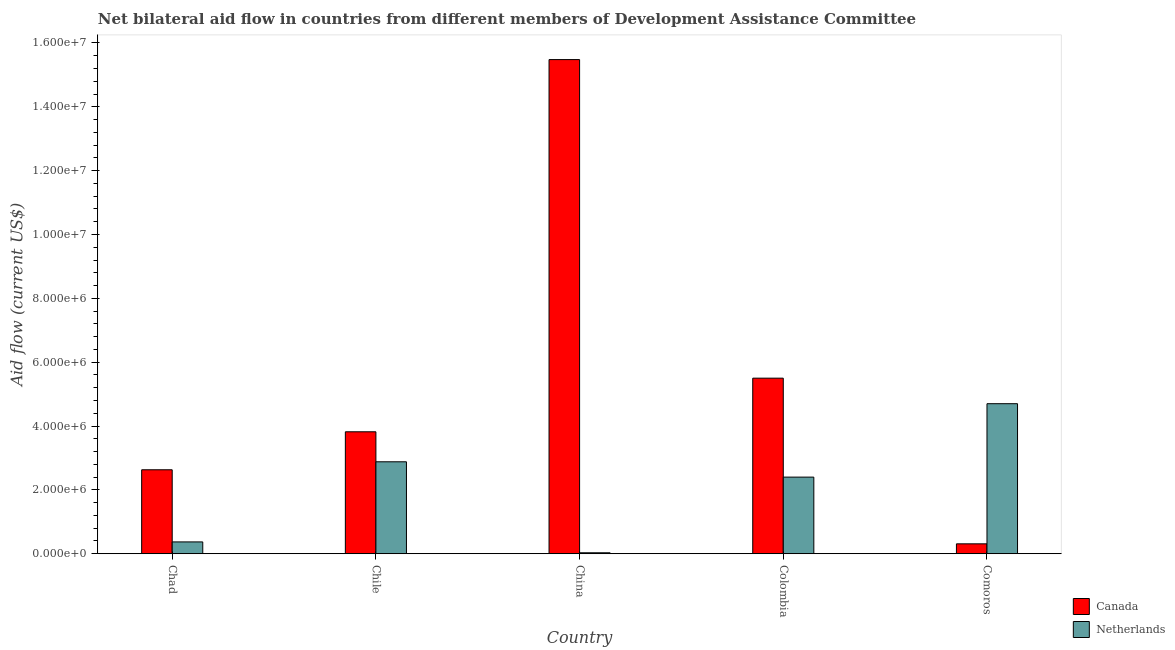How many different coloured bars are there?
Keep it short and to the point. 2. How many groups of bars are there?
Your response must be concise. 5. Are the number of bars on each tick of the X-axis equal?
Your answer should be very brief. Yes. What is the label of the 4th group of bars from the left?
Offer a very short reply. Colombia. What is the amount of aid given by netherlands in Colombia?
Your response must be concise. 2.40e+06. Across all countries, what is the maximum amount of aid given by netherlands?
Keep it short and to the point. 4.70e+06. Across all countries, what is the minimum amount of aid given by netherlands?
Give a very brief answer. 3.00e+04. In which country was the amount of aid given by netherlands maximum?
Give a very brief answer. Comoros. In which country was the amount of aid given by canada minimum?
Keep it short and to the point. Comoros. What is the total amount of aid given by canada in the graph?
Your answer should be compact. 2.77e+07. What is the difference between the amount of aid given by canada in Chile and that in China?
Give a very brief answer. -1.17e+07. What is the difference between the amount of aid given by canada in Comoros and the amount of aid given by netherlands in Colombia?
Your answer should be very brief. -2.09e+06. What is the average amount of aid given by netherlands per country?
Keep it short and to the point. 2.08e+06. What is the difference between the amount of aid given by canada and amount of aid given by netherlands in Chile?
Keep it short and to the point. 9.40e+05. In how many countries, is the amount of aid given by canada greater than 7200000 US$?
Your answer should be compact. 1. What is the ratio of the amount of aid given by netherlands in China to that in Comoros?
Your answer should be compact. 0.01. Is the amount of aid given by netherlands in China less than that in Comoros?
Offer a terse response. Yes. Is the difference between the amount of aid given by canada in Chad and Chile greater than the difference between the amount of aid given by netherlands in Chad and Chile?
Give a very brief answer. Yes. What is the difference between the highest and the second highest amount of aid given by canada?
Give a very brief answer. 9.98e+06. What is the difference between the highest and the lowest amount of aid given by canada?
Ensure brevity in your answer.  1.52e+07. Is the sum of the amount of aid given by canada in Colombia and Comoros greater than the maximum amount of aid given by netherlands across all countries?
Provide a succinct answer. Yes. What does the 2nd bar from the left in Chad represents?
Your answer should be compact. Netherlands. What does the 2nd bar from the right in Colombia represents?
Ensure brevity in your answer.  Canada. How many bars are there?
Your answer should be very brief. 10. How many countries are there in the graph?
Make the answer very short. 5. Where does the legend appear in the graph?
Keep it short and to the point. Bottom right. What is the title of the graph?
Your answer should be very brief. Net bilateral aid flow in countries from different members of Development Assistance Committee. What is the Aid flow (current US$) of Canada in Chad?
Your answer should be very brief. 2.63e+06. What is the Aid flow (current US$) in Canada in Chile?
Your response must be concise. 3.82e+06. What is the Aid flow (current US$) of Netherlands in Chile?
Ensure brevity in your answer.  2.88e+06. What is the Aid flow (current US$) of Canada in China?
Keep it short and to the point. 1.55e+07. What is the Aid flow (current US$) of Canada in Colombia?
Offer a terse response. 5.50e+06. What is the Aid flow (current US$) in Netherlands in Colombia?
Your answer should be very brief. 2.40e+06. What is the Aid flow (current US$) of Netherlands in Comoros?
Provide a succinct answer. 4.70e+06. Across all countries, what is the maximum Aid flow (current US$) in Canada?
Give a very brief answer. 1.55e+07. Across all countries, what is the maximum Aid flow (current US$) of Netherlands?
Provide a short and direct response. 4.70e+06. Across all countries, what is the minimum Aid flow (current US$) of Canada?
Keep it short and to the point. 3.10e+05. Across all countries, what is the minimum Aid flow (current US$) of Netherlands?
Provide a short and direct response. 3.00e+04. What is the total Aid flow (current US$) of Canada in the graph?
Offer a terse response. 2.77e+07. What is the total Aid flow (current US$) of Netherlands in the graph?
Provide a short and direct response. 1.04e+07. What is the difference between the Aid flow (current US$) in Canada in Chad and that in Chile?
Provide a succinct answer. -1.19e+06. What is the difference between the Aid flow (current US$) of Netherlands in Chad and that in Chile?
Keep it short and to the point. -2.51e+06. What is the difference between the Aid flow (current US$) in Canada in Chad and that in China?
Provide a short and direct response. -1.28e+07. What is the difference between the Aid flow (current US$) in Canada in Chad and that in Colombia?
Provide a short and direct response. -2.87e+06. What is the difference between the Aid flow (current US$) in Netherlands in Chad and that in Colombia?
Make the answer very short. -2.03e+06. What is the difference between the Aid flow (current US$) in Canada in Chad and that in Comoros?
Ensure brevity in your answer.  2.32e+06. What is the difference between the Aid flow (current US$) in Netherlands in Chad and that in Comoros?
Ensure brevity in your answer.  -4.33e+06. What is the difference between the Aid flow (current US$) of Canada in Chile and that in China?
Make the answer very short. -1.17e+07. What is the difference between the Aid flow (current US$) of Netherlands in Chile and that in China?
Your response must be concise. 2.85e+06. What is the difference between the Aid flow (current US$) of Canada in Chile and that in Colombia?
Your response must be concise. -1.68e+06. What is the difference between the Aid flow (current US$) in Canada in Chile and that in Comoros?
Your answer should be compact. 3.51e+06. What is the difference between the Aid flow (current US$) in Netherlands in Chile and that in Comoros?
Offer a very short reply. -1.82e+06. What is the difference between the Aid flow (current US$) in Canada in China and that in Colombia?
Keep it short and to the point. 9.98e+06. What is the difference between the Aid flow (current US$) of Netherlands in China and that in Colombia?
Your answer should be very brief. -2.37e+06. What is the difference between the Aid flow (current US$) in Canada in China and that in Comoros?
Ensure brevity in your answer.  1.52e+07. What is the difference between the Aid flow (current US$) in Netherlands in China and that in Comoros?
Ensure brevity in your answer.  -4.67e+06. What is the difference between the Aid flow (current US$) of Canada in Colombia and that in Comoros?
Make the answer very short. 5.19e+06. What is the difference between the Aid flow (current US$) in Netherlands in Colombia and that in Comoros?
Offer a very short reply. -2.30e+06. What is the difference between the Aid flow (current US$) of Canada in Chad and the Aid flow (current US$) of Netherlands in Chile?
Make the answer very short. -2.50e+05. What is the difference between the Aid flow (current US$) of Canada in Chad and the Aid flow (current US$) of Netherlands in China?
Your answer should be compact. 2.60e+06. What is the difference between the Aid flow (current US$) in Canada in Chad and the Aid flow (current US$) in Netherlands in Colombia?
Offer a very short reply. 2.30e+05. What is the difference between the Aid flow (current US$) in Canada in Chad and the Aid flow (current US$) in Netherlands in Comoros?
Your answer should be very brief. -2.07e+06. What is the difference between the Aid flow (current US$) in Canada in Chile and the Aid flow (current US$) in Netherlands in China?
Your response must be concise. 3.79e+06. What is the difference between the Aid flow (current US$) of Canada in Chile and the Aid flow (current US$) of Netherlands in Colombia?
Make the answer very short. 1.42e+06. What is the difference between the Aid flow (current US$) in Canada in Chile and the Aid flow (current US$) in Netherlands in Comoros?
Offer a very short reply. -8.80e+05. What is the difference between the Aid flow (current US$) in Canada in China and the Aid flow (current US$) in Netherlands in Colombia?
Make the answer very short. 1.31e+07. What is the difference between the Aid flow (current US$) in Canada in China and the Aid flow (current US$) in Netherlands in Comoros?
Provide a short and direct response. 1.08e+07. What is the difference between the Aid flow (current US$) of Canada in Colombia and the Aid flow (current US$) of Netherlands in Comoros?
Offer a very short reply. 8.00e+05. What is the average Aid flow (current US$) of Canada per country?
Provide a succinct answer. 5.55e+06. What is the average Aid flow (current US$) in Netherlands per country?
Keep it short and to the point. 2.08e+06. What is the difference between the Aid flow (current US$) of Canada and Aid flow (current US$) of Netherlands in Chad?
Make the answer very short. 2.26e+06. What is the difference between the Aid flow (current US$) of Canada and Aid flow (current US$) of Netherlands in Chile?
Offer a very short reply. 9.40e+05. What is the difference between the Aid flow (current US$) of Canada and Aid flow (current US$) of Netherlands in China?
Give a very brief answer. 1.54e+07. What is the difference between the Aid flow (current US$) of Canada and Aid flow (current US$) of Netherlands in Colombia?
Make the answer very short. 3.10e+06. What is the difference between the Aid flow (current US$) in Canada and Aid flow (current US$) in Netherlands in Comoros?
Keep it short and to the point. -4.39e+06. What is the ratio of the Aid flow (current US$) in Canada in Chad to that in Chile?
Make the answer very short. 0.69. What is the ratio of the Aid flow (current US$) of Netherlands in Chad to that in Chile?
Give a very brief answer. 0.13. What is the ratio of the Aid flow (current US$) in Canada in Chad to that in China?
Your answer should be very brief. 0.17. What is the ratio of the Aid flow (current US$) in Netherlands in Chad to that in China?
Your answer should be very brief. 12.33. What is the ratio of the Aid flow (current US$) of Canada in Chad to that in Colombia?
Keep it short and to the point. 0.48. What is the ratio of the Aid flow (current US$) of Netherlands in Chad to that in Colombia?
Provide a short and direct response. 0.15. What is the ratio of the Aid flow (current US$) of Canada in Chad to that in Comoros?
Offer a very short reply. 8.48. What is the ratio of the Aid flow (current US$) of Netherlands in Chad to that in Comoros?
Provide a short and direct response. 0.08. What is the ratio of the Aid flow (current US$) of Canada in Chile to that in China?
Offer a terse response. 0.25. What is the ratio of the Aid flow (current US$) in Netherlands in Chile to that in China?
Offer a very short reply. 96. What is the ratio of the Aid flow (current US$) of Canada in Chile to that in Colombia?
Offer a very short reply. 0.69. What is the ratio of the Aid flow (current US$) of Netherlands in Chile to that in Colombia?
Your answer should be very brief. 1.2. What is the ratio of the Aid flow (current US$) in Canada in Chile to that in Comoros?
Your answer should be compact. 12.32. What is the ratio of the Aid flow (current US$) of Netherlands in Chile to that in Comoros?
Make the answer very short. 0.61. What is the ratio of the Aid flow (current US$) in Canada in China to that in Colombia?
Give a very brief answer. 2.81. What is the ratio of the Aid flow (current US$) in Netherlands in China to that in Colombia?
Provide a short and direct response. 0.01. What is the ratio of the Aid flow (current US$) of Canada in China to that in Comoros?
Your answer should be compact. 49.94. What is the ratio of the Aid flow (current US$) in Netherlands in China to that in Comoros?
Your answer should be very brief. 0.01. What is the ratio of the Aid flow (current US$) in Canada in Colombia to that in Comoros?
Provide a short and direct response. 17.74. What is the ratio of the Aid flow (current US$) of Netherlands in Colombia to that in Comoros?
Keep it short and to the point. 0.51. What is the difference between the highest and the second highest Aid flow (current US$) of Canada?
Give a very brief answer. 9.98e+06. What is the difference between the highest and the second highest Aid flow (current US$) in Netherlands?
Offer a terse response. 1.82e+06. What is the difference between the highest and the lowest Aid flow (current US$) of Canada?
Your answer should be very brief. 1.52e+07. What is the difference between the highest and the lowest Aid flow (current US$) of Netherlands?
Make the answer very short. 4.67e+06. 